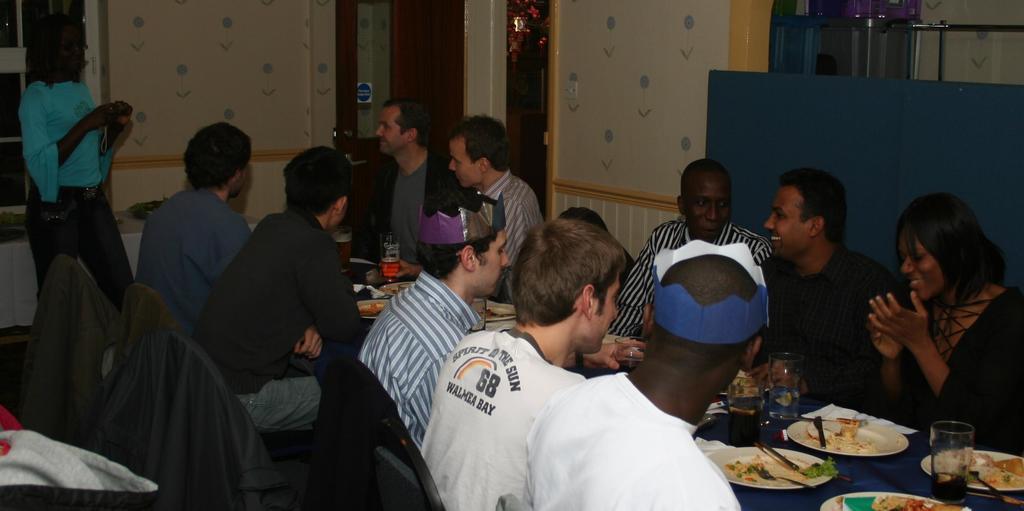How would you summarize this image in a sentence or two? In the image there are a group of people sitting around the table and having dinner, on the table there are many food items and drinks. In the background there is a woman standing in front of a wall and capturing the photo of the people. Behind the woman there is a window and on the right side there is door. 